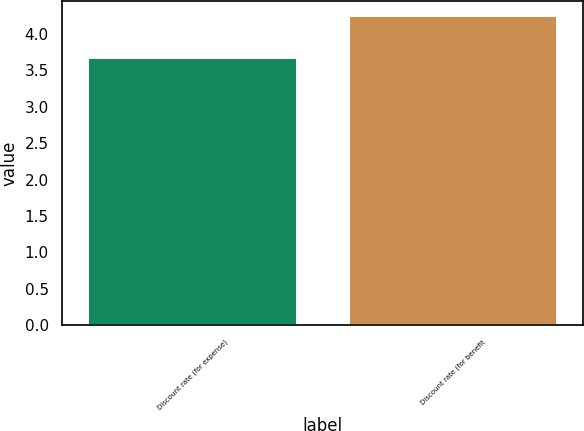Convert chart to OTSL. <chart><loc_0><loc_0><loc_500><loc_500><bar_chart><fcel>Discount rate (for expense)<fcel>Discount rate (for benefit<nl><fcel>3.67<fcel>4.24<nl></chart> 